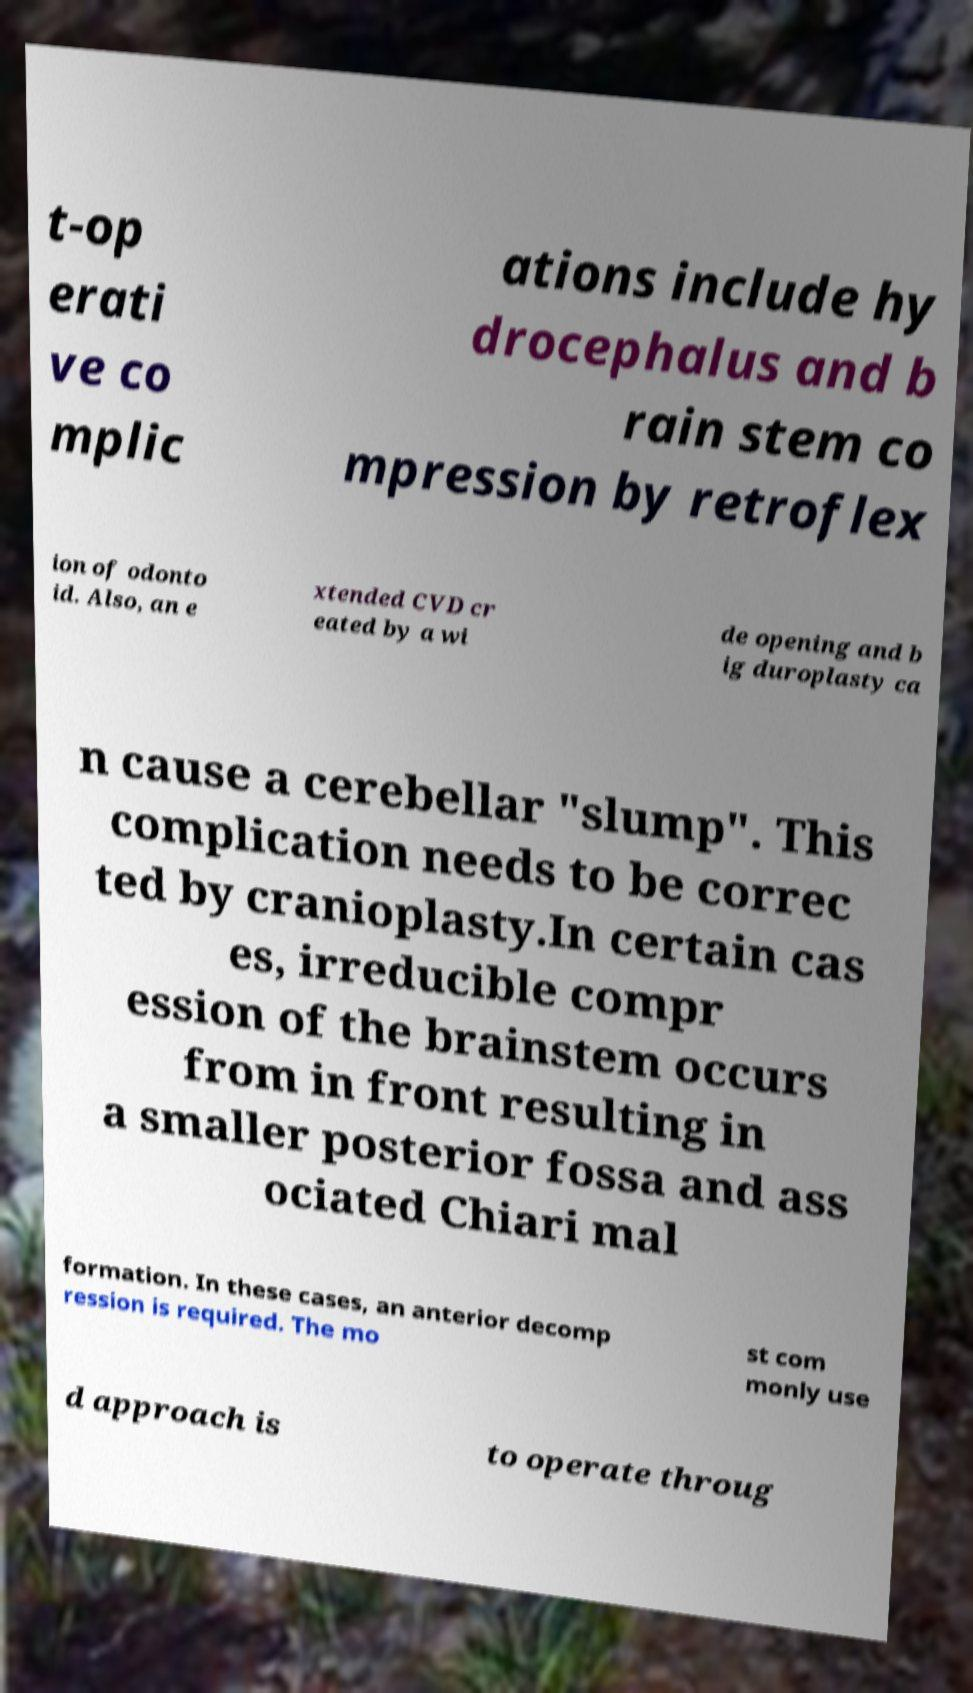There's text embedded in this image that I need extracted. Can you transcribe it verbatim? t-op erati ve co mplic ations include hy drocephalus and b rain stem co mpression by retroflex ion of odonto id. Also, an e xtended CVD cr eated by a wi de opening and b ig duroplasty ca n cause a cerebellar "slump". This complication needs to be correc ted by cranioplasty.In certain cas es, irreducible compr ession of the brainstem occurs from in front resulting in a smaller posterior fossa and ass ociated Chiari mal formation. In these cases, an anterior decomp ression is required. The mo st com monly use d approach is to operate throug 